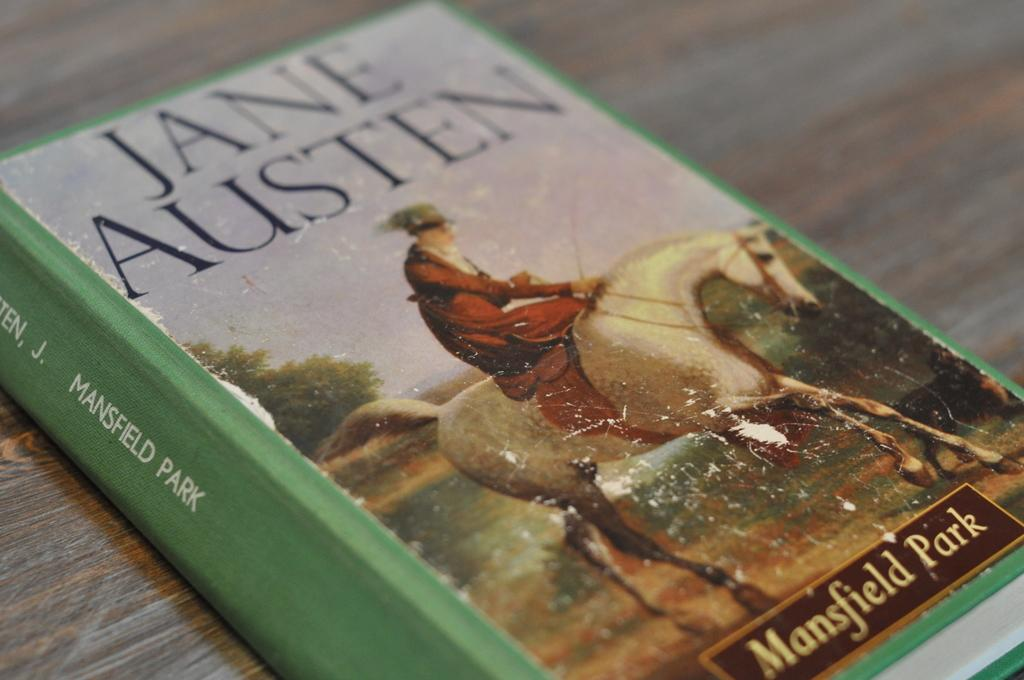What object is placed on the table in the image? There is a book on the table in the image. What is the title of the book? The name of the book is Jane Austen. Can you describe the image below the book? There is an image of a person sitting on a horse under the book. What type of mask is the person wearing in the image? There is no person wearing a mask in the image; it features an image of a person sitting on a horse. How many trains are visible in the image? There are no trains present in the image. 